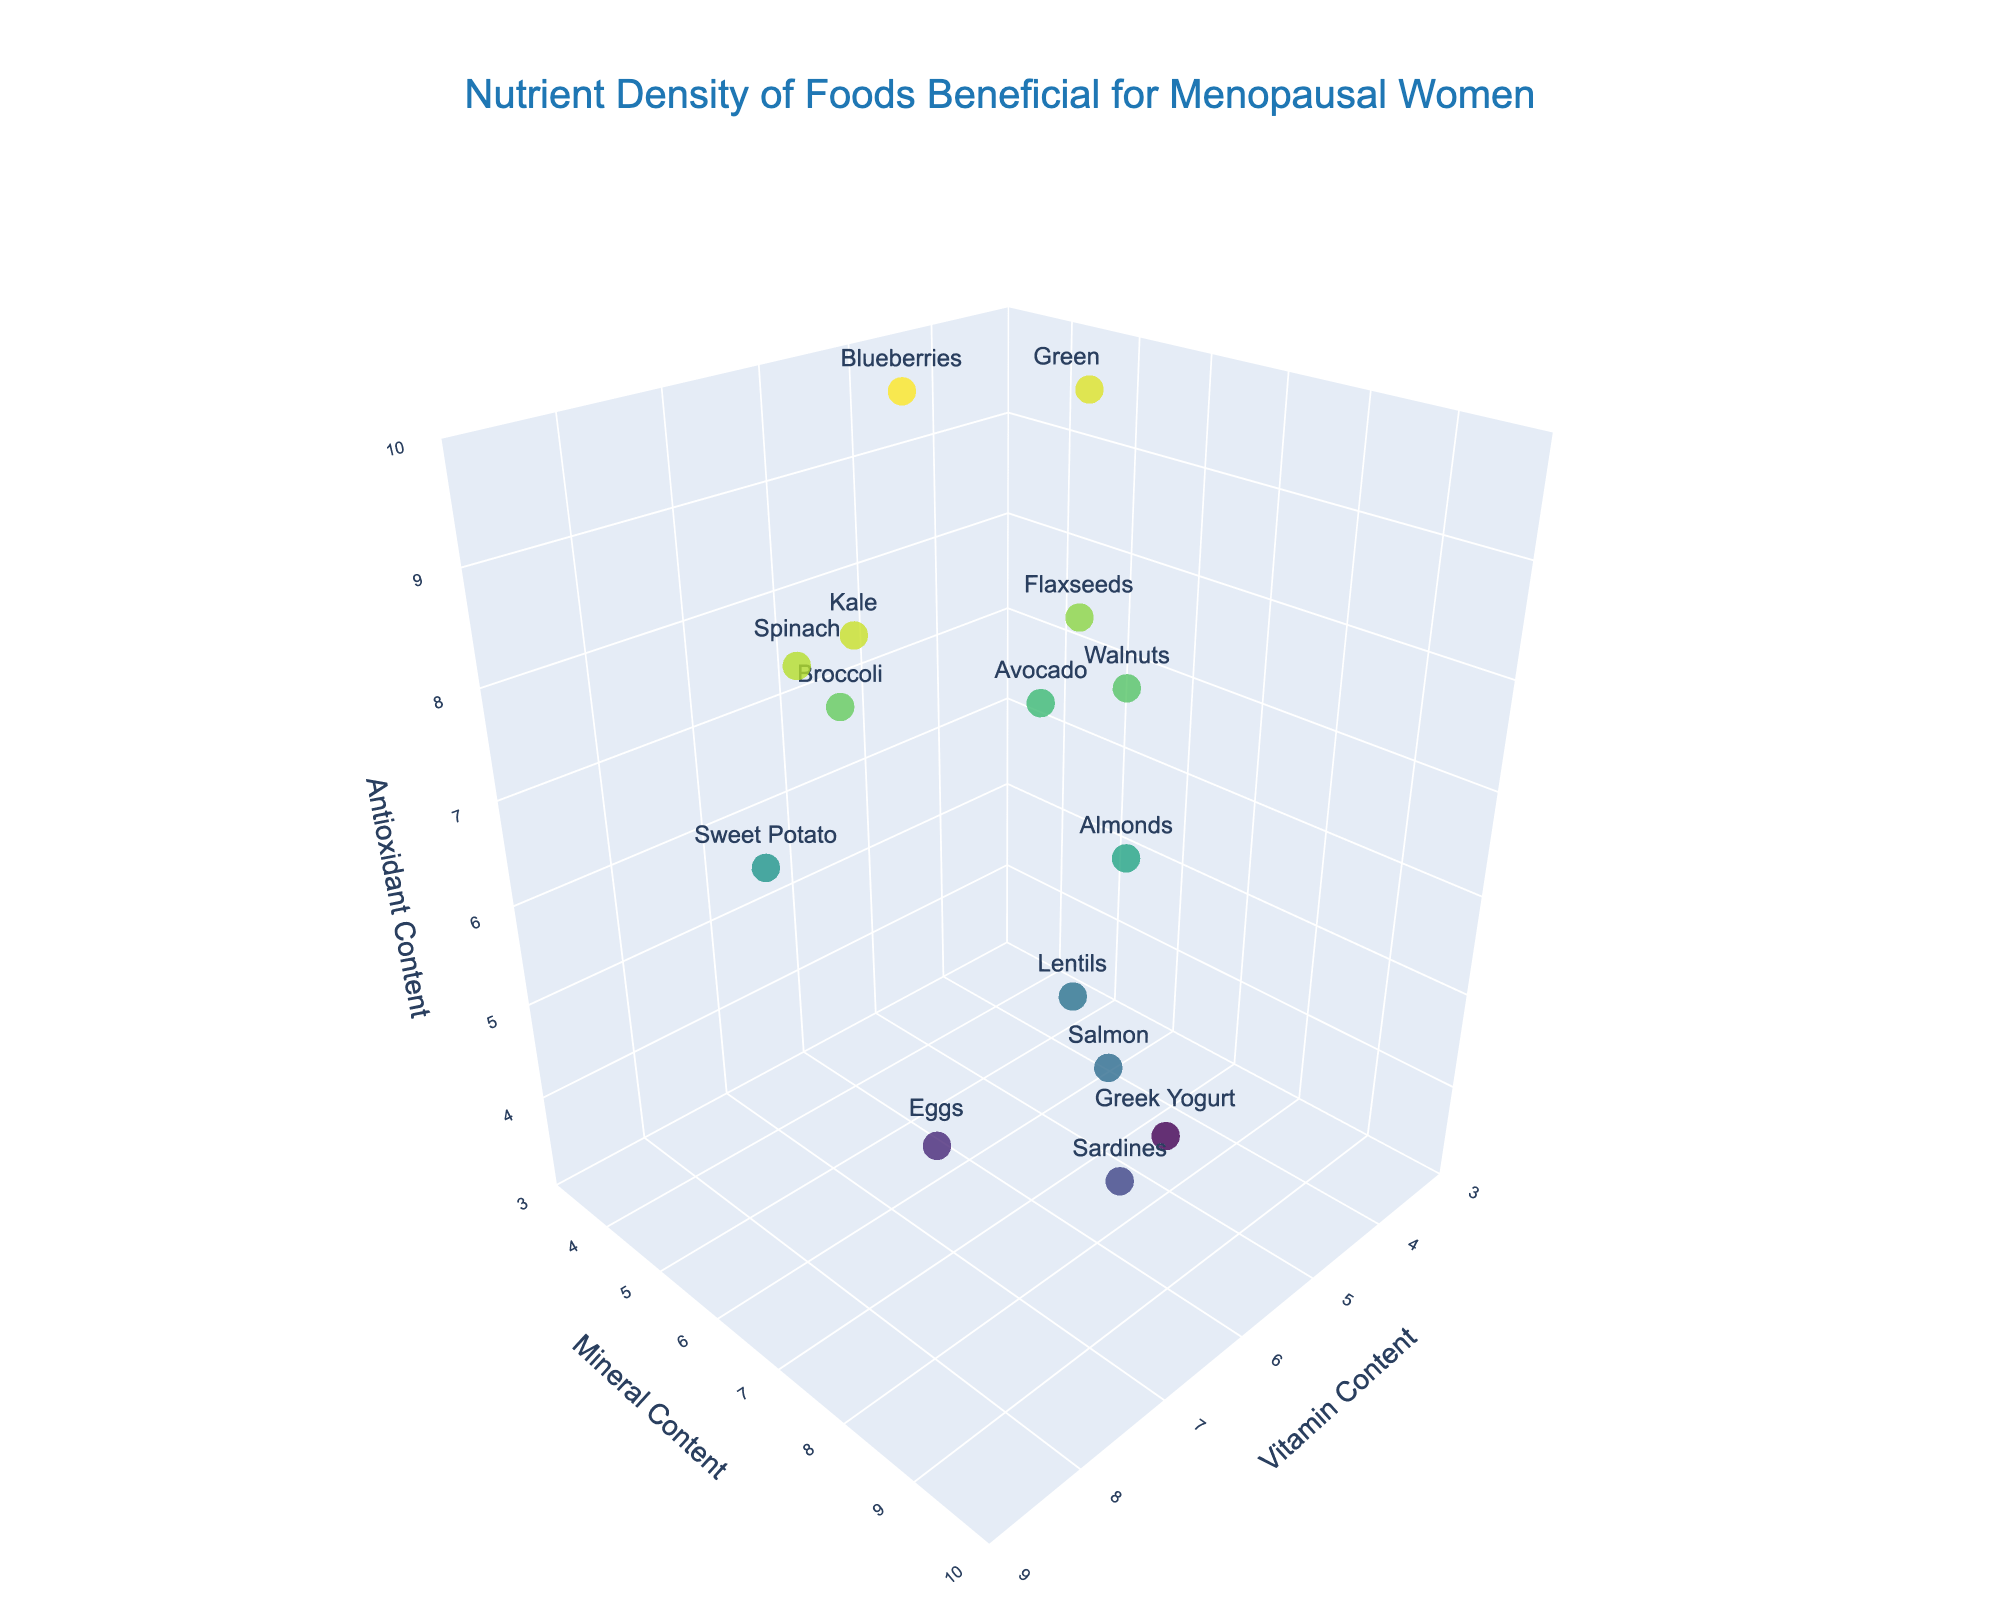What is the title of the figure? The title of the figure is located at the top center of the plot, and it reads "Nutrient Density of Foods Beneficial for Menopausal Women".
Answer: Nutrient Density of Foods Beneficial for Menopausal Women Which food has the highest antioxidant content? By examining the vertical axis (Antioxidant Content) and looking for the data point at the highest value, Blueberries have the highest antioxidant content with a value of 9.8.
Answer: Blueberries How many food items have a vitamin content of 7 or higher? Look along the horizontal axis (Vitamin Content) to identify food items with values 7 or above. The foods meeting this criterion are Spinach, Broccoli, Sweet Potato, Kale, and Eggs, making a total of 5 items.
Answer: 5 Which food is balanced across vitamins, minerals, and antioxidants, being close to an average position in the plot? A balanced food would be near the center on all three axes. Broccoli, with values of 7.6 for vitamins, 6.4 for minerals, and 8.3 for antioxidants, is close to an average in all aspects.
Answer: Broccoli What is the range of mineral content values displayed in the plot? To find the range, observe the lowest and highest points along the vertical axis representing Mineral Content. The minimum value is 4.1 (Blueberries) and the maximum value is 9.2 (Sardines). The range is 9.2 - 4.1.
Answer: 5.1 Which food has the highest mineral content and what is its antioxidant content? The highest mineral content is for Sardines with a value of 9.2. The antioxidant content for Sardines can be read off the plot and is 4.8.
Answer: Sardines, 4.8 Which food has the lowest vitamin content and how does it compare in antioxidant content? The lowest vitamin content is in Green Tea with a value of 3.2. Its antioxidant content is very high at 9.5.
Answer: Green Tea, 9.5 Compare the nutrient density of Spinach and Almonds. Which has higher vitamin content and which has higher mineral content? Spinach has a vitamin content of 8.5, higher than Almonds at 6.3. Almonds, however, have a mineral content of 8.5, whereas Spinach has 7.2.
Answer: Spinach, Almonds Between Greek Yogurt and Avocado, which has higher antioxidant content and which one has a higher mineral content? Greek Yogurt has a lower antioxidant content of 3.5 compared to Avocado's 7.8. Greek Yogurt has a mineral content of 7.8, slightly higher than Avocado's 6.7.
Answer: Avocado, Greek Yogurt Which food items lie closest to the point (6, 8, 8) in terms of their nutrient contents? Identify food items with nutrient values close to (6, 8, 8). Flaxseeds have content values of 5.8 (V), 7.3 (M), and 8.7 (A), which are closest to the given point.
Answer: Flaxseeds 